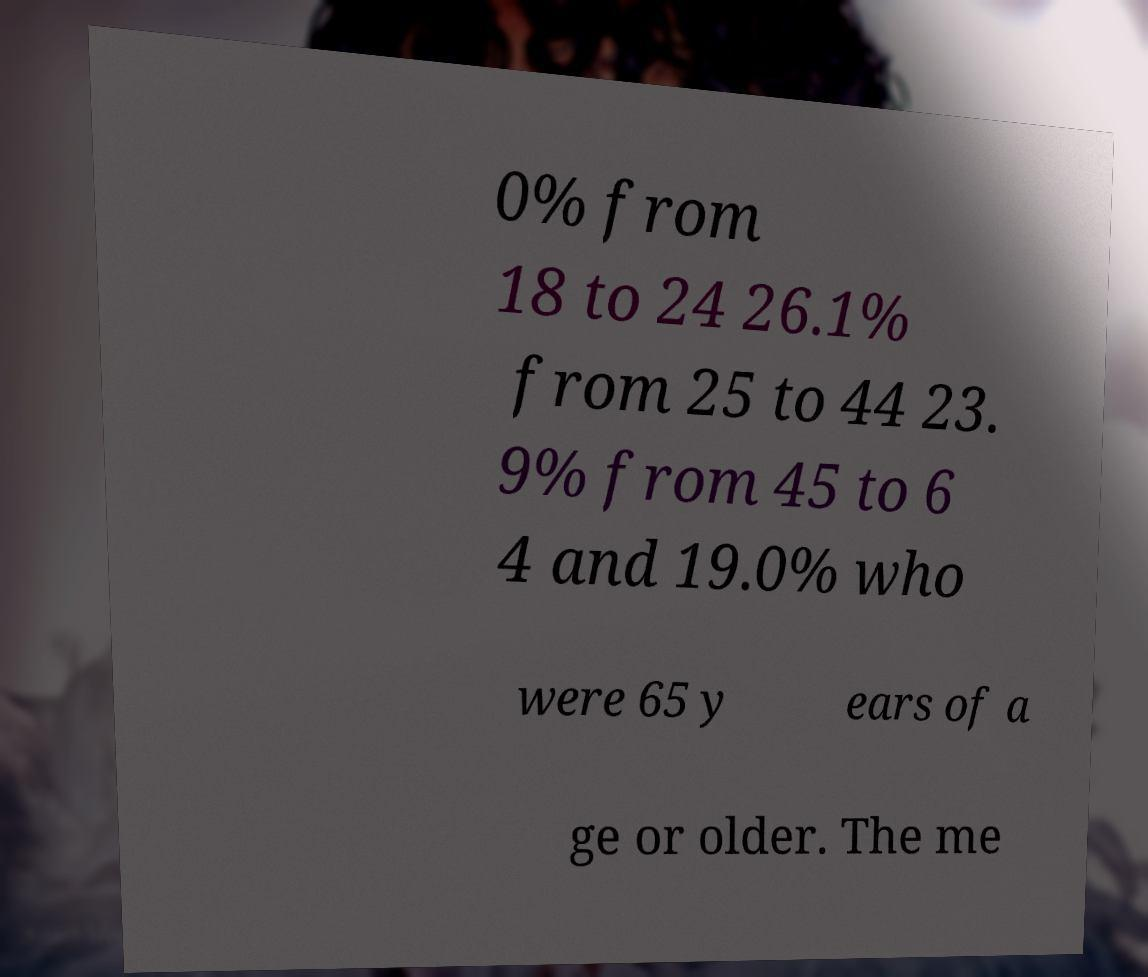Please identify and transcribe the text found in this image. 0% from 18 to 24 26.1% from 25 to 44 23. 9% from 45 to 6 4 and 19.0% who were 65 y ears of a ge or older. The me 